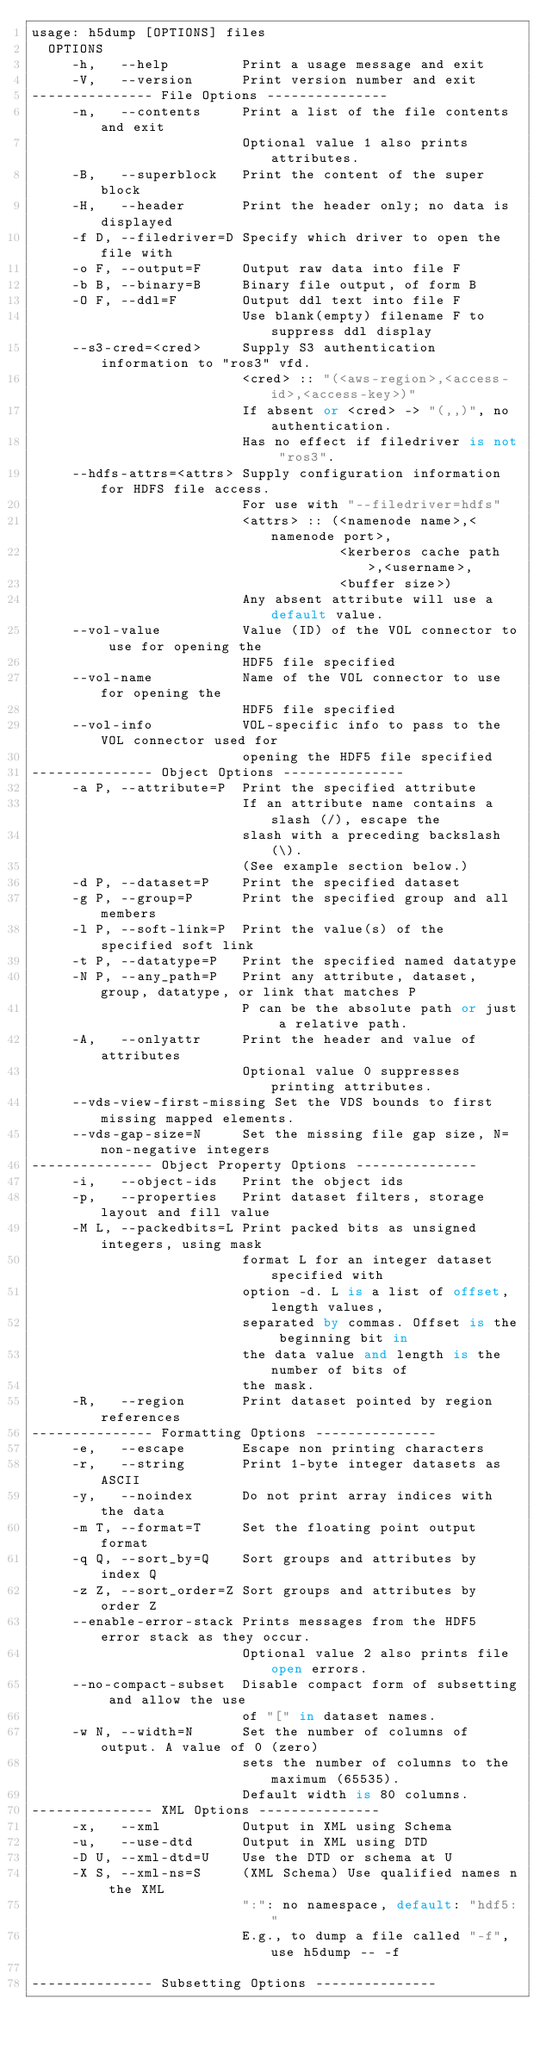Convert code to text. <code><loc_0><loc_0><loc_500><loc_500><_SQL_>usage: h5dump [OPTIONS] files
  OPTIONS
     -h,   --help         Print a usage message and exit
     -V,   --version      Print version number and exit
--------------- File Options ---------------
     -n,   --contents     Print a list of the file contents and exit
                          Optional value 1 also prints attributes.
     -B,   --superblock   Print the content of the super block
     -H,   --header       Print the header only; no data is displayed
     -f D, --filedriver=D Specify which driver to open the file with
     -o F, --output=F     Output raw data into file F
     -b B, --binary=B     Binary file output, of form B
     -O F, --ddl=F        Output ddl text into file F
                          Use blank(empty) filename F to suppress ddl display
     --s3-cred=<cred>     Supply S3 authentication information to "ros3" vfd.
                          <cred> :: "(<aws-region>,<access-id>,<access-key>)"
                          If absent or <cred> -> "(,,)", no authentication.
                          Has no effect if filedriver is not "ros3".
     --hdfs-attrs=<attrs> Supply configuration information for HDFS file access.
                          For use with "--filedriver=hdfs"
                          <attrs> :: (<namenode name>,<namenode port>,
                                      <kerberos cache path>,<username>,
                                      <buffer size>)
                          Any absent attribute will use a default value.
     --vol-value          Value (ID) of the VOL connector to use for opening the
                          HDF5 file specified
     --vol-name           Name of the VOL connector to use for opening the
                          HDF5 file specified
     --vol-info           VOL-specific info to pass to the VOL connector used for
                          opening the HDF5 file specified
--------------- Object Options ---------------
     -a P, --attribute=P  Print the specified attribute
                          If an attribute name contains a slash (/), escape the
                          slash with a preceding backslash (\).
                          (See example section below.)
     -d P, --dataset=P    Print the specified dataset
     -g P, --group=P      Print the specified group and all members
     -l P, --soft-link=P  Print the value(s) of the specified soft link
     -t P, --datatype=P   Print the specified named datatype
     -N P, --any_path=P   Print any attribute, dataset, group, datatype, or link that matches P
                          P can be the absolute path or just a relative path.
     -A,   --onlyattr     Print the header and value of attributes
                          Optional value 0 suppresses printing attributes.
     --vds-view-first-missing Set the VDS bounds to first missing mapped elements.
     --vds-gap-size=N     Set the missing file gap size, N=non-negative integers
--------------- Object Property Options ---------------
     -i,   --object-ids   Print the object ids
     -p,   --properties   Print dataset filters, storage layout and fill value
     -M L, --packedbits=L Print packed bits as unsigned integers, using mask
                          format L for an integer dataset specified with
                          option -d. L is a list of offset,length values,
                          separated by commas. Offset is the beginning bit in
                          the data value and length is the number of bits of
                          the mask.
     -R,   --region       Print dataset pointed by region references
--------------- Formatting Options ---------------
     -e,   --escape       Escape non printing characters
     -r,   --string       Print 1-byte integer datasets as ASCII
     -y,   --noindex      Do not print array indices with the data
     -m T, --format=T     Set the floating point output format
     -q Q, --sort_by=Q    Sort groups and attributes by index Q
     -z Z, --sort_order=Z Sort groups and attributes by order Z
     --enable-error-stack Prints messages from the HDF5 error stack as they occur.
                          Optional value 2 also prints file open errors.
     --no-compact-subset  Disable compact form of subsetting and allow the use
                          of "[" in dataset names.
     -w N, --width=N      Set the number of columns of output. A value of 0 (zero)
                          sets the number of columns to the maximum (65535).
                          Default width is 80 columns.
--------------- XML Options ---------------
     -x,   --xml          Output in XML using Schema
     -u,   --use-dtd      Output in XML using DTD
     -D U, --xml-dtd=U    Use the DTD or schema at U
     -X S, --xml-ns=S     (XML Schema) Use qualified names n the XML
                          ":": no namespace, default: "hdf5:"
                          E.g., to dump a file called "-f", use h5dump -- -f

--------------- Subsetting Options ---------------</code> 